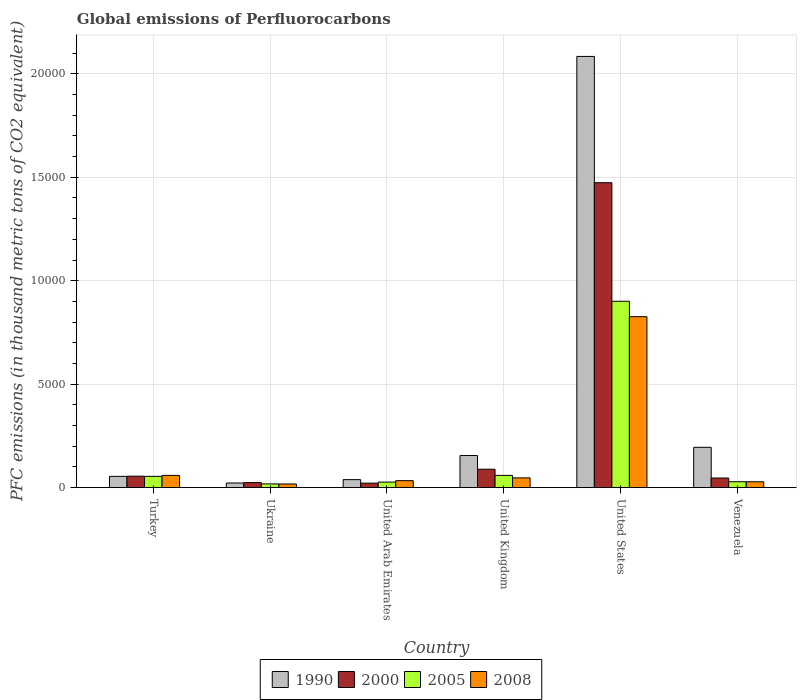How many different coloured bars are there?
Make the answer very short. 4. How many bars are there on the 4th tick from the right?
Provide a succinct answer. 4. What is the label of the 2nd group of bars from the left?
Ensure brevity in your answer.  Ukraine. In how many cases, is the number of bars for a given country not equal to the number of legend labels?
Your answer should be compact. 0. What is the global emissions of Perfluorocarbons in 2008 in United States?
Provide a succinct answer. 8264. Across all countries, what is the maximum global emissions of Perfluorocarbons in 2000?
Provide a succinct answer. 1.47e+04. Across all countries, what is the minimum global emissions of Perfluorocarbons in 2005?
Ensure brevity in your answer.  180.5. In which country was the global emissions of Perfluorocarbons in 2008 maximum?
Make the answer very short. United States. In which country was the global emissions of Perfluorocarbons in 2000 minimum?
Offer a very short reply. United Arab Emirates. What is the total global emissions of Perfluorocarbons in 2005 in the graph?
Offer a terse response. 1.09e+04. What is the difference between the global emissions of Perfluorocarbons in 2005 in United Arab Emirates and that in Venezuela?
Your response must be concise. -18.2. What is the difference between the global emissions of Perfluorocarbons in 2005 in Venezuela and the global emissions of Perfluorocarbons in 1990 in United States?
Offer a terse response. -2.06e+04. What is the average global emissions of Perfluorocarbons in 2008 per country?
Provide a succinct answer. 1687.62. What is the difference between the global emissions of Perfluorocarbons of/in 2005 and global emissions of Perfluorocarbons of/in 2000 in Ukraine?
Make the answer very short. -63.6. In how many countries, is the global emissions of Perfluorocarbons in 2000 greater than 2000 thousand metric tons?
Keep it short and to the point. 1. What is the ratio of the global emissions of Perfluorocarbons in 2005 in Ukraine to that in United Arab Emirates?
Provide a succinct answer. 0.67. Is the difference between the global emissions of Perfluorocarbons in 2005 in Ukraine and Venezuela greater than the difference between the global emissions of Perfluorocarbons in 2000 in Ukraine and Venezuela?
Ensure brevity in your answer.  Yes. What is the difference between the highest and the second highest global emissions of Perfluorocarbons in 2000?
Offer a terse response. -1.38e+04. What is the difference between the highest and the lowest global emissions of Perfluorocarbons in 1990?
Your answer should be very brief. 2.06e+04. Is the sum of the global emissions of Perfluorocarbons in 2000 in Turkey and United States greater than the maximum global emissions of Perfluorocarbons in 2005 across all countries?
Your answer should be compact. Yes. What does the 3rd bar from the right in Venezuela represents?
Keep it short and to the point. 2000. Is it the case that in every country, the sum of the global emissions of Perfluorocarbons in 1990 and global emissions of Perfluorocarbons in 2008 is greater than the global emissions of Perfluorocarbons in 2000?
Make the answer very short. Yes. What is the difference between two consecutive major ticks on the Y-axis?
Provide a short and direct response. 5000. Where does the legend appear in the graph?
Your response must be concise. Bottom center. What is the title of the graph?
Provide a succinct answer. Global emissions of Perfluorocarbons. What is the label or title of the X-axis?
Your answer should be compact. Country. What is the label or title of the Y-axis?
Make the answer very short. PFC emissions (in thousand metric tons of CO2 equivalent). What is the PFC emissions (in thousand metric tons of CO2 equivalent) in 1990 in Turkey?
Make the answer very short. 545.6. What is the PFC emissions (in thousand metric tons of CO2 equivalent) in 2000 in Turkey?
Your response must be concise. 554.9. What is the PFC emissions (in thousand metric tons of CO2 equivalent) in 2005 in Turkey?
Keep it short and to the point. 545.9. What is the PFC emissions (in thousand metric tons of CO2 equivalent) in 2008 in Turkey?
Provide a short and direct response. 591.4. What is the PFC emissions (in thousand metric tons of CO2 equivalent) of 1990 in Ukraine?
Keep it short and to the point. 224. What is the PFC emissions (in thousand metric tons of CO2 equivalent) in 2000 in Ukraine?
Give a very brief answer. 244.1. What is the PFC emissions (in thousand metric tons of CO2 equivalent) in 2005 in Ukraine?
Keep it short and to the point. 180.5. What is the PFC emissions (in thousand metric tons of CO2 equivalent) in 2008 in Ukraine?
Your response must be concise. 176.5. What is the PFC emissions (in thousand metric tons of CO2 equivalent) of 1990 in United Arab Emirates?
Provide a short and direct response. 387.3. What is the PFC emissions (in thousand metric tons of CO2 equivalent) of 2000 in United Arab Emirates?
Provide a succinct answer. 218. What is the PFC emissions (in thousand metric tons of CO2 equivalent) in 2005 in United Arab Emirates?
Your answer should be compact. 267.9. What is the PFC emissions (in thousand metric tons of CO2 equivalent) in 2008 in United Arab Emirates?
Provide a short and direct response. 337.6. What is the PFC emissions (in thousand metric tons of CO2 equivalent) in 1990 in United Kingdom?
Give a very brief answer. 1552.5. What is the PFC emissions (in thousand metric tons of CO2 equivalent) of 2000 in United Kingdom?
Provide a succinct answer. 890.1. What is the PFC emissions (in thousand metric tons of CO2 equivalent) in 2005 in United Kingdom?
Offer a terse response. 591.4. What is the PFC emissions (in thousand metric tons of CO2 equivalent) in 2008 in United Kingdom?
Give a very brief answer. 472.4. What is the PFC emissions (in thousand metric tons of CO2 equivalent) of 1990 in United States?
Your answer should be very brief. 2.08e+04. What is the PFC emissions (in thousand metric tons of CO2 equivalent) of 2000 in United States?
Your response must be concise. 1.47e+04. What is the PFC emissions (in thousand metric tons of CO2 equivalent) in 2005 in United States?
Your response must be concise. 9008.7. What is the PFC emissions (in thousand metric tons of CO2 equivalent) in 2008 in United States?
Give a very brief answer. 8264. What is the PFC emissions (in thousand metric tons of CO2 equivalent) of 1990 in Venezuela?
Ensure brevity in your answer.  1948.7. What is the PFC emissions (in thousand metric tons of CO2 equivalent) of 2000 in Venezuela?
Make the answer very short. 464.6. What is the PFC emissions (in thousand metric tons of CO2 equivalent) in 2005 in Venezuela?
Make the answer very short. 286.1. What is the PFC emissions (in thousand metric tons of CO2 equivalent) of 2008 in Venezuela?
Provide a short and direct response. 283.8. Across all countries, what is the maximum PFC emissions (in thousand metric tons of CO2 equivalent) of 1990?
Your response must be concise. 2.08e+04. Across all countries, what is the maximum PFC emissions (in thousand metric tons of CO2 equivalent) in 2000?
Offer a terse response. 1.47e+04. Across all countries, what is the maximum PFC emissions (in thousand metric tons of CO2 equivalent) in 2005?
Offer a terse response. 9008.7. Across all countries, what is the maximum PFC emissions (in thousand metric tons of CO2 equivalent) of 2008?
Make the answer very short. 8264. Across all countries, what is the minimum PFC emissions (in thousand metric tons of CO2 equivalent) in 1990?
Provide a succinct answer. 224. Across all countries, what is the minimum PFC emissions (in thousand metric tons of CO2 equivalent) of 2000?
Keep it short and to the point. 218. Across all countries, what is the minimum PFC emissions (in thousand metric tons of CO2 equivalent) in 2005?
Make the answer very short. 180.5. Across all countries, what is the minimum PFC emissions (in thousand metric tons of CO2 equivalent) of 2008?
Your answer should be compact. 176.5. What is the total PFC emissions (in thousand metric tons of CO2 equivalent) of 1990 in the graph?
Provide a short and direct response. 2.55e+04. What is the total PFC emissions (in thousand metric tons of CO2 equivalent) of 2000 in the graph?
Make the answer very short. 1.71e+04. What is the total PFC emissions (in thousand metric tons of CO2 equivalent) in 2005 in the graph?
Keep it short and to the point. 1.09e+04. What is the total PFC emissions (in thousand metric tons of CO2 equivalent) in 2008 in the graph?
Make the answer very short. 1.01e+04. What is the difference between the PFC emissions (in thousand metric tons of CO2 equivalent) in 1990 in Turkey and that in Ukraine?
Provide a succinct answer. 321.6. What is the difference between the PFC emissions (in thousand metric tons of CO2 equivalent) of 2000 in Turkey and that in Ukraine?
Make the answer very short. 310.8. What is the difference between the PFC emissions (in thousand metric tons of CO2 equivalent) in 2005 in Turkey and that in Ukraine?
Provide a succinct answer. 365.4. What is the difference between the PFC emissions (in thousand metric tons of CO2 equivalent) of 2008 in Turkey and that in Ukraine?
Your answer should be very brief. 414.9. What is the difference between the PFC emissions (in thousand metric tons of CO2 equivalent) in 1990 in Turkey and that in United Arab Emirates?
Your answer should be compact. 158.3. What is the difference between the PFC emissions (in thousand metric tons of CO2 equivalent) in 2000 in Turkey and that in United Arab Emirates?
Your response must be concise. 336.9. What is the difference between the PFC emissions (in thousand metric tons of CO2 equivalent) of 2005 in Turkey and that in United Arab Emirates?
Your response must be concise. 278. What is the difference between the PFC emissions (in thousand metric tons of CO2 equivalent) of 2008 in Turkey and that in United Arab Emirates?
Provide a short and direct response. 253.8. What is the difference between the PFC emissions (in thousand metric tons of CO2 equivalent) in 1990 in Turkey and that in United Kingdom?
Give a very brief answer. -1006.9. What is the difference between the PFC emissions (in thousand metric tons of CO2 equivalent) in 2000 in Turkey and that in United Kingdom?
Give a very brief answer. -335.2. What is the difference between the PFC emissions (in thousand metric tons of CO2 equivalent) of 2005 in Turkey and that in United Kingdom?
Ensure brevity in your answer.  -45.5. What is the difference between the PFC emissions (in thousand metric tons of CO2 equivalent) in 2008 in Turkey and that in United Kingdom?
Offer a terse response. 119. What is the difference between the PFC emissions (in thousand metric tons of CO2 equivalent) of 1990 in Turkey and that in United States?
Your answer should be compact. -2.03e+04. What is the difference between the PFC emissions (in thousand metric tons of CO2 equivalent) in 2000 in Turkey and that in United States?
Provide a succinct answer. -1.42e+04. What is the difference between the PFC emissions (in thousand metric tons of CO2 equivalent) of 2005 in Turkey and that in United States?
Your answer should be very brief. -8462.8. What is the difference between the PFC emissions (in thousand metric tons of CO2 equivalent) in 2008 in Turkey and that in United States?
Provide a short and direct response. -7672.6. What is the difference between the PFC emissions (in thousand metric tons of CO2 equivalent) of 1990 in Turkey and that in Venezuela?
Your answer should be very brief. -1403.1. What is the difference between the PFC emissions (in thousand metric tons of CO2 equivalent) of 2000 in Turkey and that in Venezuela?
Keep it short and to the point. 90.3. What is the difference between the PFC emissions (in thousand metric tons of CO2 equivalent) of 2005 in Turkey and that in Venezuela?
Your response must be concise. 259.8. What is the difference between the PFC emissions (in thousand metric tons of CO2 equivalent) in 2008 in Turkey and that in Venezuela?
Your response must be concise. 307.6. What is the difference between the PFC emissions (in thousand metric tons of CO2 equivalent) of 1990 in Ukraine and that in United Arab Emirates?
Ensure brevity in your answer.  -163.3. What is the difference between the PFC emissions (in thousand metric tons of CO2 equivalent) in 2000 in Ukraine and that in United Arab Emirates?
Your answer should be compact. 26.1. What is the difference between the PFC emissions (in thousand metric tons of CO2 equivalent) of 2005 in Ukraine and that in United Arab Emirates?
Ensure brevity in your answer.  -87.4. What is the difference between the PFC emissions (in thousand metric tons of CO2 equivalent) of 2008 in Ukraine and that in United Arab Emirates?
Give a very brief answer. -161.1. What is the difference between the PFC emissions (in thousand metric tons of CO2 equivalent) of 1990 in Ukraine and that in United Kingdom?
Ensure brevity in your answer.  -1328.5. What is the difference between the PFC emissions (in thousand metric tons of CO2 equivalent) in 2000 in Ukraine and that in United Kingdom?
Your answer should be compact. -646. What is the difference between the PFC emissions (in thousand metric tons of CO2 equivalent) of 2005 in Ukraine and that in United Kingdom?
Give a very brief answer. -410.9. What is the difference between the PFC emissions (in thousand metric tons of CO2 equivalent) of 2008 in Ukraine and that in United Kingdom?
Your response must be concise. -295.9. What is the difference between the PFC emissions (in thousand metric tons of CO2 equivalent) of 1990 in Ukraine and that in United States?
Offer a terse response. -2.06e+04. What is the difference between the PFC emissions (in thousand metric tons of CO2 equivalent) of 2000 in Ukraine and that in United States?
Make the answer very short. -1.45e+04. What is the difference between the PFC emissions (in thousand metric tons of CO2 equivalent) of 2005 in Ukraine and that in United States?
Ensure brevity in your answer.  -8828.2. What is the difference between the PFC emissions (in thousand metric tons of CO2 equivalent) in 2008 in Ukraine and that in United States?
Ensure brevity in your answer.  -8087.5. What is the difference between the PFC emissions (in thousand metric tons of CO2 equivalent) in 1990 in Ukraine and that in Venezuela?
Ensure brevity in your answer.  -1724.7. What is the difference between the PFC emissions (in thousand metric tons of CO2 equivalent) in 2000 in Ukraine and that in Venezuela?
Offer a terse response. -220.5. What is the difference between the PFC emissions (in thousand metric tons of CO2 equivalent) of 2005 in Ukraine and that in Venezuela?
Provide a succinct answer. -105.6. What is the difference between the PFC emissions (in thousand metric tons of CO2 equivalent) in 2008 in Ukraine and that in Venezuela?
Keep it short and to the point. -107.3. What is the difference between the PFC emissions (in thousand metric tons of CO2 equivalent) in 1990 in United Arab Emirates and that in United Kingdom?
Offer a very short reply. -1165.2. What is the difference between the PFC emissions (in thousand metric tons of CO2 equivalent) of 2000 in United Arab Emirates and that in United Kingdom?
Make the answer very short. -672.1. What is the difference between the PFC emissions (in thousand metric tons of CO2 equivalent) in 2005 in United Arab Emirates and that in United Kingdom?
Make the answer very short. -323.5. What is the difference between the PFC emissions (in thousand metric tons of CO2 equivalent) in 2008 in United Arab Emirates and that in United Kingdom?
Make the answer very short. -134.8. What is the difference between the PFC emissions (in thousand metric tons of CO2 equivalent) of 1990 in United Arab Emirates and that in United States?
Give a very brief answer. -2.05e+04. What is the difference between the PFC emissions (in thousand metric tons of CO2 equivalent) in 2000 in United Arab Emirates and that in United States?
Your response must be concise. -1.45e+04. What is the difference between the PFC emissions (in thousand metric tons of CO2 equivalent) of 2005 in United Arab Emirates and that in United States?
Your response must be concise. -8740.8. What is the difference between the PFC emissions (in thousand metric tons of CO2 equivalent) of 2008 in United Arab Emirates and that in United States?
Provide a succinct answer. -7926.4. What is the difference between the PFC emissions (in thousand metric tons of CO2 equivalent) of 1990 in United Arab Emirates and that in Venezuela?
Your response must be concise. -1561.4. What is the difference between the PFC emissions (in thousand metric tons of CO2 equivalent) in 2000 in United Arab Emirates and that in Venezuela?
Your response must be concise. -246.6. What is the difference between the PFC emissions (in thousand metric tons of CO2 equivalent) in 2005 in United Arab Emirates and that in Venezuela?
Your answer should be compact. -18.2. What is the difference between the PFC emissions (in thousand metric tons of CO2 equivalent) in 2008 in United Arab Emirates and that in Venezuela?
Give a very brief answer. 53.8. What is the difference between the PFC emissions (in thousand metric tons of CO2 equivalent) of 1990 in United Kingdom and that in United States?
Your answer should be very brief. -1.93e+04. What is the difference between the PFC emissions (in thousand metric tons of CO2 equivalent) of 2000 in United Kingdom and that in United States?
Offer a very short reply. -1.38e+04. What is the difference between the PFC emissions (in thousand metric tons of CO2 equivalent) in 2005 in United Kingdom and that in United States?
Make the answer very short. -8417.3. What is the difference between the PFC emissions (in thousand metric tons of CO2 equivalent) in 2008 in United Kingdom and that in United States?
Your response must be concise. -7791.6. What is the difference between the PFC emissions (in thousand metric tons of CO2 equivalent) in 1990 in United Kingdom and that in Venezuela?
Keep it short and to the point. -396.2. What is the difference between the PFC emissions (in thousand metric tons of CO2 equivalent) in 2000 in United Kingdom and that in Venezuela?
Give a very brief answer. 425.5. What is the difference between the PFC emissions (in thousand metric tons of CO2 equivalent) of 2005 in United Kingdom and that in Venezuela?
Offer a very short reply. 305.3. What is the difference between the PFC emissions (in thousand metric tons of CO2 equivalent) of 2008 in United Kingdom and that in Venezuela?
Offer a very short reply. 188.6. What is the difference between the PFC emissions (in thousand metric tons of CO2 equivalent) in 1990 in United States and that in Venezuela?
Provide a short and direct response. 1.89e+04. What is the difference between the PFC emissions (in thousand metric tons of CO2 equivalent) of 2000 in United States and that in Venezuela?
Make the answer very short. 1.43e+04. What is the difference between the PFC emissions (in thousand metric tons of CO2 equivalent) in 2005 in United States and that in Venezuela?
Make the answer very short. 8722.6. What is the difference between the PFC emissions (in thousand metric tons of CO2 equivalent) in 2008 in United States and that in Venezuela?
Give a very brief answer. 7980.2. What is the difference between the PFC emissions (in thousand metric tons of CO2 equivalent) of 1990 in Turkey and the PFC emissions (in thousand metric tons of CO2 equivalent) of 2000 in Ukraine?
Your answer should be compact. 301.5. What is the difference between the PFC emissions (in thousand metric tons of CO2 equivalent) of 1990 in Turkey and the PFC emissions (in thousand metric tons of CO2 equivalent) of 2005 in Ukraine?
Give a very brief answer. 365.1. What is the difference between the PFC emissions (in thousand metric tons of CO2 equivalent) in 1990 in Turkey and the PFC emissions (in thousand metric tons of CO2 equivalent) in 2008 in Ukraine?
Offer a very short reply. 369.1. What is the difference between the PFC emissions (in thousand metric tons of CO2 equivalent) of 2000 in Turkey and the PFC emissions (in thousand metric tons of CO2 equivalent) of 2005 in Ukraine?
Your answer should be very brief. 374.4. What is the difference between the PFC emissions (in thousand metric tons of CO2 equivalent) in 2000 in Turkey and the PFC emissions (in thousand metric tons of CO2 equivalent) in 2008 in Ukraine?
Make the answer very short. 378.4. What is the difference between the PFC emissions (in thousand metric tons of CO2 equivalent) of 2005 in Turkey and the PFC emissions (in thousand metric tons of CO2 equivalent) of 2008 in Ukraine?
Keep it short and to the point. 369.4. What is the difference between the PFC emissions (in thousand metric tons of CO2 equivalent) in 1990 in Turkey and the PFC emissions (in thousand metric tons of CO2 equivalent) in 2000 in United Arab Emirates?
Give a very brief answer. 327.6. What is the difference between the PFC emissions (in thousand metric tons of CO2 equivalent) of 1990 in Turkey and the PFC emissions (in thousand metric tons of CO2 equivalent) of 2005 in United Arab Emirates?
Keep it short and to the point. 277.7. What is the difference between the PFC emissions (in thousand metric tons of CO2 equivalent) in 1990 in Turkey and the PFC emissions (in thousand metric tons of CO2 equivalent) in 2008 in United Arab Emirates?
Make the answer very short. 208. What is the difference between the PFC emissions (in thousand metric tons of CO2 equivalent) in 2000 in Turkey and the PFC emissions (in thousand metric tons of CO2 equivalent) in 2005 in United Arab Emirates?
Provide a short and direct response. 287. What is the difference between the PFC emissions (in thousand metric tons of CO2 equivalent) of 2000 in Turkey and the PFC emissions (in thousand metric tons of CO2 equivalent) of 2008 in United Arab Emirates?
Offer a very short reply. 217.3. What is the difference between the PFC emissions (in thousand metric tons of CO2 equivalent) in 2005 in Turkey and the PFC emissions (in thousand metric tons of CO2 equivalent) in 2008 in United Arab Emirates?
Keep it short and to the point. 208.3. What is the difference between the PFC emissions (in thousand metric tons of CO2 equivalent) in 1990 in Turkey and the PFC emissions (in thousand metric tons of CO2 equivalent) in 2000 in United Kingdom?
Make the answer very short. -344.5. What is the difference between the PFC emissions (in thousand metric tons of CO2 equivalent) of 1990 in Turkey and the PFC emissions (in thousand metric tons of CO2 equivalent) of 2005 in United Kingdom?
Your response must be concise. -45.8. What is the difference between the PFC emissions (in thousand metric tons of CO2 equivalent) in 1990 in Turkey and the PFC emissions (in thousand metric tons of CO2 equivalent) in 2008 in United Kingdom?
Offer a very short reply. 73.2. What is the difference between the PFC emissions (in thousand metric tons of CO2 equivalent) in 2000 in Turkey and the PFC emissions (in thousand metric tons of CO2 equivalent) in 2005 in United Kingdom?
Give a very brief answer. -36.5. What is the difference between the PFC emissions (in thousand metric tons of CO2 equivalent) in 2000 in Turkey and the PFC emissions (in thousand metric tons of CO2 equivalent) in 2008 in United Kingdom?
Your response must be concise. 82.5. What is the difference between the PFC emissions (in thousand metric tons of CO2 equivalent) in 2005 in Turkey and the PFC emissions (in thousand metric tons of CO2 equivalent) in 2008 in United Kingdom?
Your answer should be very brief. 73.5. What is the difference between the PFC emissions (in thousand metric tons of CO2 equivalent) of 1990 in Turkey and the PFC emissions (in thousand metric tons of CO2 equivalent) of 2000 in United States?
Your answer should be compact. -1.42e+04. What is the difference between the PFC emissions (in thousand metric tons of CO2 equivalent) of 1990 in Turkey and the PFC emissions (in thousand metric tons of CO2 equivalent) of 2005 in United States?
Your answer should be compact. -8463.1. What is the difference between the PFC emissions (in thousand metric tons of CO2 equivalent) of 1990 in Turkey and the PFC emissions (in thousand metric tons of CO2 equivalent) of 2008 in United States?
Offer a very short reply. -7718.4. What is the difference between the PFC emissions (in thousand metric tons of CO2 equivalent) in 2000 in Turkey and the PFC emissions (in thousand metric tons of CO2 equivalent) in 2005 in United States?
Your answer should be compact. -8453.8. What is the difference between the PFC emissions (in thousand metric tons of CO2 equivalent) of 2000 in Turkey and the PFC emissions (in thousand metric tons of CO2 equivalent) of 2008 in United States?
Keep it short and to the point. -7709.1. What is the difference between the PFC emissions (in thousand metric tons of CO2 equivalent) of 2005 in Turkey and the PFC emissions (in thousand metric tons of CO2 equivalent) of 2008 in United States?
Your answer should be compact. -7718.1. What is the difference between the PFC emissions (in thousand metric tons of CO2 equivalent) in 1990 in Turkey and the PFC emissions (in thousand metric tons of CO2 equivalent) in 2000 in Venezuela?
Keep it short and to the point. 81. What is the difference between the PFC emissions (in thousand metric tons of CO2 equivalent) of 1990 in Turkey and the PFC emissions (in thousand metric tons of CO2 equivalent) of 2005 in Venezuela?
Your response must be concise. 259.5. What is the difference between the PFC emissions (in thousand metric tons of CO2 equivalent) of 1990 in Turkey and the PFC emissions (in thousand metric tons of CO2 equivalent) of 2008 in Venezuela?
Your answer should be very brief. 261.8. What is the difference between the PFC emissions (in thousand metric tons of CO2 equivalent) in 2000 in Turkey and the PFC emissions (in thousand metric tons of CO2 equivalent) in 2005 in Venezuela?
Offer a terse response. 268.8. What is the difference between the PFC emissions (in thousand metric tons of CO2 equivalent) in 2000 in Turkey and the PFC emissions (in thousand metric tons of CO2 equivalent) in 2008 in Venezuela?
Provide a succinct answer. 271.1. What is the difference between the PFC emissions (in thousand metric tons of CO2 equivalent) in 2005 in Turkey and the PFC emissions (in thousand metric tons of CO2 equivalent) in 2008 in Venezuela?
Your answer should be compact. 262.1. What is the difference between the PFC emissions (in thousand metric tons of CO2 equivalent) of 1990 in Ukraine and the PFC emissions (in thousand metric tons of CO2 equivalent) of 2000 in United Arab Emirates?
Keep it short and to the point. 6. What is the difference between the PFC emissions (in thousand metric tons of CO2 equivalent) in 1990 in Ukraine and the PFC emissions (in thousand metric tons of CO2 equivalent) in 2005 in United Arab Emirates?
Offer a terse response. -43.9. What is the difference between the PFC emissions (in thousand metric tons of CO2 equivalent) in 1990 in Ukraine and the PFC emissions (in thousand metric tons of CO2 equivalent) in 2008 in United Arab Emirates?
Give a very brief answer. -113.6. What is the difference between the PFC emissions (in thousand metric tons of CO2 equivalent) in 2000 in Ukraine and the PFC emissions (in thousand metric tons of CO2 equivalent) in 2005 in United Arab Emirates?
Give a very brief answer. -23.8. What is the difference between the PFC emissions (in thousand metric tons of CO2 equivalent) of 2000 in Ukraine and the PFC emissions (in thousand metric tons of CO2 equivalent) of 2008 in United Arab Emirates?
Give a very brief answer. -93.5. What is the difference between the PFC emissions (in thousand metric tons of CO2 equivalent) in 2005 in Ukraine and the PFC emissions (in thousand metric tons of CO2 equivalent) in 2008 in United Arab Emirates?
Ensure brevity in your answer.  -157.1. What is the difference between the PFC emissions (in thousand metric tons of CO2 equivalent) of 1990 in Ukraine and the PFC emissions (in thousand metric tons of CO2 equivalent) of 2000 in United Kingdom?
Your answer should be compact. -666.1. What is the difference between the PFC emissions (in thousand metric tons of CO2 equivalent) of 1990 in Ukraine and the PFC emissions (in thousand metric tons of CO2 equivalent) of 2005 in United Kingdom?
Your answer should be compact. -367.4. What is the difference between the PFC emissions (in thousand metric tons of CO2 equivalent) of 1990 in Ukraine and the PFC emissions (in thousand metric tons of CO2 equivalent) of 2008 in United Kingdom?
Give a very brief answer. -248.4. What is the difference between the PFC emissions (in thousand metric tons of CO2 equivalent) in 2000 in Ukraine and the PFC emissions (in thousand metric tons of CO2 equivalent) in 2005 in United Kingdom?
Give a very brief answer. -347.3. What is the difference between the PFC emissions (in thousand metric tons of CO2 equivalent) of 2000 in Ukraine and the PFC emissions (in thousand metric tons of CO2 equivalent) of 2008 in United Kingdom?
Offer a terse response. -228.3. What is the difference between the PFC emissions (in thousand metric tons of CO2 equivalent) of 2005 in Ukraine and the PFC emissions (in thousand metric tons of CO2 equivalent) of 2008 in United Kingdom?
Offer a very short reply. -291.9. What is the difference between the PFC emissions (in thousand metric tons of CO2 equivalent) in 1990 in Ukraine and the PFC emissions (in thousand metric tons of CO2 equivalent) in 2000 in United States?
Keep it short and to the point. -1.45e+04. What is the difference between the PFC emissions (in thousand metric tons of CO2 equivalent) in 1990 in Ukraine and the PFC emissions (in thousand metric tons of CO2 equivalent) in 2005 in United States?
Ensure brevity in your answer.  -8784.7. What is the difference between the PFC emissions (in thousand metric tons of CO2 equivalent) in 1990 in Ukraine and the PFC emissions (in thousand metric tons of CO2 equivalent) in 2008 in United States?
Give a very brief answer. -8040. What is the difference between the PFC emissions (in thousand metric tons of CO2 equivalent) of 2000 in Ukraine and the PFC emissions (in thousand metric tons of CO2 equivalent) of 2005 in United States?
Your response must be concise. -8764.6. What is the difference between the PFC emissions (in thousand metric tons of CO2 equivalent) of 2000 in Ukraine and the PFC emissions (in thousand metric tons of CO2 equivalent) of 2008 in United States?
Ensure brevity in your answer.  -8019.9. What is the difference between the PFC emissions (in thousand metric tons of CO2 equivalent) of 2005 in Ukraine and the PFC emissions (in thousand metric tons of CO2 equivalent) of 2008 in United States?
Offer a very short reply. -8083.5. What is the difference between the PFC emissions (in thousand metric tons of CO2 equivalent) of 1990 in Ukraine and the PFC emissions (in thousand metric tons of CO2 equivalent) of 2000 in Venezuela?
Provide a succinct answer. -240.6. What is the difference between the PFC emissions (in thousand metric tons of CO2 equivalent) of 1990 in Ukraine and the PFC emissions (in thousand metric tons of CO2 equivalent) of 2005 in Venezuela?
Your answer should be very brief. -62.1. What is the difference between the PFC emissions (in thousand metric tons of CO2 equivalent) in 1990 in Ukraine and the PFC emissions (in thousand metric tons of CO2 equivalent) in 2008 in Venezuela?
Offer a terse response. -59.8. What is the difference between the PFC emissions (in thousand metric tons of CO2 equivalent) in 2000 in Ukraine and the PFC emissions (in thousand metric tons of CO2 equivalent) in 2005 in Venezuela?
Your response must be concise. -42. What is the difference between the PFC emissions (in thousand metric tons of CO2 equivalent) in 2000 in Ukraine and the PFC emissions (in thousand metric tons of CO2 equivalent) in 2008 in Venezuela?
Your answer should be very brief. -39.7. What is the difference between the PFC emissions (in thousand metric tons of CO2 equivalent) in 2005 in Ukraine and the PFC emissions (in thousand metric tons of CO2 equivalent) in 2008 in Venezuela?
Provide a succinct answer. -103.3. What is the difference between the PFC emissions (in thousand metric tons of CO2 equivalent) in 1990 in United Arab Emirates and the PFC emissions (in thousand metric tons of CO2 equivalent) in 2000 in United Kingdom?
Your answer should be very brief. -502.8. What is the difference between the PFC emissions (in thousand metric tons of CO2 equivalent) in 1990 in United Arab Emirates and the PFC emissions (in thousand metric tons of CO2 equivalent) in 2005 in United Kingdom?
Your answer should be compact. -204.1. What is the difference between the PFC emissions (in thousand metric tons of CO2 equivalent) of 1990 in United Arab Emirates and the PFC emissions (in thousand metric tons of CO2 equivalent) of 2008 in United Kingdom?
Your answer should be compact. -85.1. What is the difference between the PFC emissions (in thousand metric tons of CO2 equivalent) in 2000 in United Arab Emirates and the PFC emissions (in thousand metric tons of CO2 equivalent) in 2005 in United Kingdom?
Make the answer very short. -373.4. What is the difference between the PFC emissions (in thousand metric tons of CO2 equivalent) in 2000 in United Arab Emirates and the PFC emissions (in thousand metric tons of CO2 equivalent) in 2008 in United Kingdom?
Give a very brief answer. -254.4. What is the difference between the PFC emissions (in thousand metric tons of CO2 equivalent) of 2005 in United Arab Emirates and the PFC emissions (in thousand metric tons of CO2 equivalent) of 2008 in United Kingdom?
Keep it short and to the point. -204.5. What is the difference between the PFC emissions (in thousand metric tons of CO2 equivalent) of 1990 in United Arab Emirates and the PFC emissions (in thousand metric tons of CO2 equivalent) of 2000 in United States?
Provide a short and direct response. -1.44e+04. What is the difference between the PFC emissions (in thousand metric tons of CO2 equivalent) in 1990 in United Arab Emirates and the PFC emissions (in thousand metric tons of CO2 equivalent) in 2005 in United States?
Ensure brevity in your answer.  -8621.4. What is the difference between the PFC emissions (in thousand metric tons of CO2 equivalent) in 1990 in United Arab Emirates and the PFC emissions (in thousand metric tons of CO2 equivalent) in 2008 in United States?
Ensure brevity in your answer.  -7876.7. What is the difference between the PFC emissions (in thousand metric tons of CO2 equivalent) of 2000 in United Arab Emirates and the PFC emissions (in thousand metric tons of CO2 equivalent) of 2005 in United States?
Keep it short and to the point. -8790.7. What is the difference between the PFC emissions (in thousand metric tons of CO2 equivalent) of 2000 in United Arab Emirates and the PFC emissions (in thousand metric tons of CO2 equivalent) of 2008 in United States?
Provide a succinct answer. -8046. What is the difference between the PFC emissions (in thousand metric tons of CO2 equivalent) of 2005 in United Arab Emirates and the PFC emissions (in thousand metric tons of CO2 equivalent) of 2008 in United States?
Make the answer very short. -7996.1. What is the difference between the PFC emissions (in thousand metric tons of CO2 equivalent) in 1990 in United Arab Emirates and the PFC emissions (in thousand metric tons of CO2 equivalent) in 2000 in Venezuela?
Ensure brevity in your answer.  -77.3. What is the difference between the PFC emissions (in thousand metric tons of CO2 equivalent) in 1990 in United Arab Emirates and the PFC emissions (in thousand metric tons of CO2 equivalent) in 2005 in Venezuela?
Give a very brief answer. 101.2. What is the difference between the PFC emissions (in thousand metric tons of CO2 equivalent) of 1990 in United Arab Emirates and the PFC emissions (in thousand metric tons of CO2 equivalent) of 2008 in Venezuela?
Make the answer very short. 103.5. What is the difference between the PFC emissions (in thousand metric tons of CO2 equivalent) of 2000 in United Arab Emirates and the PFC emissions (in thousand metric tons of CO2 equivalent) of 2005 in Venezuela?
Ensure brevity in your answer.  -68.1. What is the difference between the PFC emissions (in thousand metric tons of CO2 equivalent) in 2000 in United Arab Emirates and the PFC emissions (in thousand metric tons of CO2 equivalent) in 2008 in Venezuela?
Make the answer very short. -65.8. What is the difference between the PFC emissions (in thousand metric tons of CO2 equivalent) of 2005 in United Arab Emirates and the PFC emissions (in thousand metric tons of CO2 equivalent) of 2008 in Venezuela?
Your answer should be compact. -15.9. What is the difference between the PFC emissions (in thousand metric tons of CO2 equivalent) in 1990 in United Kingdom and the PFC emissions (in thousand metric tons of CO2 equivalent) in 2000 in United States?
Your response must be concise. -1.32e+04. What is the difference between the PFC emissions (in thousand metric tons of CO2 equivalent) in 1990 in United Kingdom and the PFC emissions (in thousand metric tons of CO2 equivalent) in 2005 in United States?
Provide a succinct answer. -7456.2. What is the difference between the PFC emissions (in thousand metric tons of CO2 equivalent) in 1990 in United Kingdom and the PFC emissions (in thousand metric tons of CO2 equivalent) in 2008 in United States?
Your answer should be compact. -6711.5. What is the difference between the PFC emissions (in thousand metric tons of CO2 equivalent) of 2000 in United Kingdom and the PFC emissions (in thousand metric tons of CO2 equivalent) of 2005 in United States?
Your answer should be compact. -8118.6. What is the difference between the PFC emissions (in thousand metric tons of CO2 equivalent) of 2000 in United Kingdom and the PFC emissions (in thousand metric tons of CO2 equivalent) of 2008 in United States?
Offer a very short reply. -7373.9. What is the difference between the PFC emissions (in thousand metric tons of CO2 equivalent) in 2005 in United Kingdom and the PFC emissions (in thousand metric tons of CO2 equivalent) in 2008 in United States?
Your answer should be compact. -7672.6. What is the difference between the PFC emissions (in thousand metric tons of CO2 equivalent) in 1990 in United Kingdom and the PFC emissions (in thousand metric tons of CO2 equivalent) in 2000 in Venezuela?
Provide a succinct answer. 1087.9. What is the difference between the PFC emissions (in thousand metric tons of CO2 equivalent) of 1990 in United Kingdom and the PFC emissions (in thousand metric tons of CO2 equivalent) of 2005 in Venezuela?
Offer a terse response. 1266.4. What is the difference between the PFC emissions (in thousand metric tons of CO2 equivalent) in 1990 in United Kingdom and the PFC emissions (in thousand metric tons of CO2 equivalent) in 2008 in Venezuela?
Offer a very short reply. 1268.7. What is the difference between the PFC emissions (in thousand metric tons of CO2 equivalent) in 2000 in United Kingdom and the PFC emissions (in thousand metric tons of CO2 equivalent) in 2005 in Venezuela?
Your answer should be very brief. 604. What is the difference between the PFC emissions (in thousand metric tons of CO2 equivalent) in 2000 in United Kingdom and the PFC emissions (in thousand metric tons of CO2 equivalent) in 2008 in Venezuela?
Keep it short and to the point. 606.3. What is the difference between the PFC emissions (in thousand metric tons of CO2 equivalent) of 2005 in United Kingdom and the PFC emissions (in thousand metric tons of CO2 equivalent) of 2008 in Venezuela?
Ensure brevity in your answer.  307.6. What is the difference between the PFC emissions (in thousand metric tons of CO2 equivalent) in 1990 in United States and the PFC emissions (in thousand metric tons of CO2 equivalent) in 2000 in Venezuela?
Make the answer very short. 2.04e+04. What is the difference between the PFC emissions (in thousand metric tons of CO2 equivalent) of 1990 in United States and the PFC emissions (in thousand metric tons of CO2 equivalent) of 2005 in Venezuela?
Your answer should be very brief. 2.06e+04. What is the difference between the PFC emissions (in thousand metric tons of CO2 equivalent) of 1990 in United States and the PFC emissions (in thousand metric tons of CO2 equivalent) of 2008 in Venezuela?
Give a very brief answer. 2.06e+04. What is the difference between the PFC emissions (in thousand metric tons of CO2 equivalent) of 2000 in United States and the PFC emissions (in thousand metric tons of CO2 equivalent) of 2005 in Venezuela?
Provide a succinct answer. 1.45e+04. What is the difference between the PFC emissions (in thousand metric tons of CO2 equivalent) of 2000 in United States and the PFC emissions (in thousand metric tons of CO2 equivalent) of 2008 in Venezuela?
Give a very brief answer. 1.45e+04. What is the difference between the PFC emissions (in thousand metric tons of CO2 equivalent) in 2005 in United States and the PFC emissions (in thousand metric tons of CO2 equivalent) in 2008 in Venezuela?
Offer a terse response. 8724.9. What is the average PFC emissions (in thousand metric tons of CO2 equivalent) of 1990 per country?
Your answer should be very brief. 4249.9. What is the average PFC emissions (in thousand metric tons of CO2 equivalent) in 2000 per country?
Offer a very short reply. 2851.78. What is the average PFC emissions (in thousand metric tons of CO2 equivalent) of 2005 per country?
Offer a very short reply. 1813.42. What is the average PFC emissions (in thousand metric tons of CO2 equivalent) of 2008 per country?
Your response must be concise. 1687.62. What is the difference between the PFC emissions (in thousand metric tons of CO2 equivalent) of 1990 and PFC emissions (in thousand metric tons of CO2 equivalent) of 2000 in Turkey?
Offer a very short reply. -9.3. What is the difference between the PFC emissions (in thousand metric tons of CO2 equivalent) in 1990 and PFC emissions (in thousand metric tons of CO2 equivalent) in 2005 in Turkey?
Give a very brief answer. -0.3. What is the difference between the PFC emissions (in thousand metric tons of CO2 equivalent) of 1990 and PFC emissions (in thousand metric tons of CO2 equivalent) of 2008 in Turkey?
Provide a succinct answer. -45.8. What is the difference between the PFC emissions (in thousand metric tons of CO2 equivalent) of 2000 and PFC emissions (in thousand metric tons of CO2 equivalent) of 2005 in Turkey?
Offer a very short reply. 9. What is the difference between the PFC emissions (in thousand metric tons of CO2 equivalent) of 2000 and PFC emissions (in thousand metric tons of CO2 equivalent) of 2008 in Turkey?
Ensure brevity in your answer.  -36.5. What is the difference between the PFC emissions (in thousand metric tons of CO2 equivalent) of 2005 and PFC emissions (in thousand metric tons of CO2 equivalent) of 2008 in Turkey?
Give a very brief answer. -45.5. What is the difference between the PFC emissions (in thousand metric tons of CO2 equivalent) in 1990 and PFC emissions (in thousand metric tons of CO2 equivalent) in 2000 in Ukraine?
Make the answer very short. -20.1. What is the difference between the PFC emissions (in thousand metric tons of CO2 equivalent) of 1990 and PFC emissions (in thousand metric tons of CO2 equivalent) of 2005 in Ukraine?
Give a very brief answer. 43.5. What is the difference between the PFC emissions (in thousand metric tons of CO2 equivalent) of 1990 and PFC emissions (in thousand metric tons of CO2 equivalent) of 2008 in Ukraine?
Give a very brief answer. 47.5. What is the difference between the PFC emissions (in thousand metric tons of CO2 equivalent) of 2000 and PFC emissions (in thousand metric tons of CO2 equivalent) of 2005 in Ukraine?
Give a very brief answer. 63.6. What is the difference between the PFC emissions (in thousand metric tons of CO2 equivalent) in 2000 and PFC emissions (in thousand metric tons of CO2 equivalent) in 2008 in Ukraine?
Provide a short and direct response. 67.6. What is the difference between the PFC emissions (in thousand metric tons of CO2 equivalent) in 1990 and PFC emissions (in thousand metric tons of CO2 equivalent) in 2000 in United Arab Emirates?
Offer a very short reply. 169.3. What is the difference between the PFC emissions (in thousand metric tons of CO2 equivalent) of 1990 and PFC emissions (in thousand metric tons of CO2 equivalent) of 2005 in United Arab Emirates?
Offer a very short reply. 119.4. What is the difference between the PFC emissions (in thousand metric tons of CO2 equivalent) of 1990 and PFC emissions (in thousand metric tons of CO2 equivalent) of 2008 in United Arab Emirates?
Provide a short and direct response. 49.7. What is the difference between the PFC emissions (in thousand metric tons of CO2 equivalent) in 2000 and PFC emissions (in thousand metric tons of CO2 equivalent) in 2005 in United Arab Emirates?
Make the answer very short. -49.9. What is the difference between the PFC emissions (in thousand metric tons of CO2 equivalent) in 2000 and PFC emissions (in thousand metric tons of CO2 equivalent) in 2008 in United Arab Emirates?
Ensure brevity in your answer.  -119.6. What is the difference between the PFC emissions (in thousand metric tons of CO2 equivalent) in 2005 and PFC emissions (in thousand metric tons of CO2 equivalent) in 2008 in United Arab Emirates?
Your answer should be very brief. -69.7. What is the difference between the PFC emissions (in thousand metric tons of CO2 equivalent) of 1990 and PFC emissions (in thousand metric tons of CO2 equivalent) of 2000 in United Kingdom?
Ensure brevity in your answer.  662.4. What is the difference between the PFC emissions (in thousand metric tons of CO2 equivalent) of 1990 and PFC emissions (in thousand metric tons of CO2 equivalent) of 2005 in United Kingdom?
Your answer should be very brief. 961.1. What is the difference between the PFC emissions (in thousand metric tons of CO2 equivalent) in 1990 and PFC emissions (in thousand metric tons of CO2 equivalent) in 2008 in United Kingdom?
Your answer should be compact. 1080.1. What is the difference between the PFC emissions (in thousand metric tons of CO2 equivalent) of 2000 and PFC emissions (in thousand metric tons of CO2 equivalent) of 2005 in United Kingdom?
Offer a terse response. 298.7. What is the difference between the PFC emissions (in thousand metric tons of CO2 equivalent) of 2000 and PFC emissions (in thousand metric tons of CO2 equivalent) of 2008 in United Kingdom?
Provide a short and direct response. 417.7. What is the difference between the PFC emissions (in thousand metric tons of CO2 equivalent) in 2005 and PFC emissions (in thousand metric tons of CO2 equivalent) in 2008 in United Kingdom?
Give a very brief answer. 119. What is the difference between the PFC emissions (in thousand metric tons of CO2 equivalent) of 1990 and PFC emissions (in thousand metric tons of CO2 equivalent) of 2000 in United States?
Make the answer very short. 6102.3. What is the difference between the PFC emissions (in thousand metric tons of CO2 equivalent) in 1990 and PFC emissions (in thousand metric tons of CO2 equivalent) in 2005 in United States?
Give a very brief answer. 1.18e+04. What is the difference between the PFC emissions (in thousand metric tons of CO2 equivalent) of 1990 and PFC emissions (in thousand metric tons of CO2 equivalent) of 2008 in United States?
Offer a very short reply. 1.26e+04. What is the difference between the PFC emissions (in thousand metric tons of CO2 equivalent) in 2000 and PFC emissions (in thousand metric tons of CO2 equivalent) in 2005 in United States?
Provide a short and direct response. 5730.3. What is the difference between the PFC emissions (in thousand metric tons of CO2 equivalent) in 2000 and PFC emissions (in thousand metric tons of CO2 equivalent) in 2008 in United States?
Your response must be concise. 6475. What is the difference between the PFC emissions (in thousand metric tons of CO2 equivalent) of 2005 and PFC emissions (in thousand metric tons of CO2 equivalent) of 2008 in United States?
Your answer should be compact. 744.7. What is the difference between the PFC emissions (in thousand metric tons of CO2 equivalent) of 1990 and PFC emissions (in thousand metric tons of CO2 equivalent) of 2000 in Venezuela?
Your answer should be very brief. 1484.1. What is the difference between the PFC emissions (in thousand metric tons of CO2 equivalent) of 1990 and PFC emissions (in thousand metric tons of CO2 equivalent) of 2005 in Venezuela?
Provide a short and direct response. 1662.6. What is the difference between the PFC emissions (in thousand metric tons of CO2 equivalent) in 1990 and PFC emissions (in thousand metric tons of CO2 equivalent) in 2008 in Venezuela?
Make the answer very short. 1664.9. What is the difference between the PFC emissions (in thousand metric tons of CO2 equivalent) in 2000 and PFC emissions (in thousand metric tons of CO2 equivalent) in 2005 in Venezuela?
Give a very brief answer. 178.5. What is the difference between the PFC emissions (in thousand metric tons of CO2 equivalent) of 2000 and PFC emissions (in thousand metric tons of CO2 equivalent) of 2008 in Venezuela?
Keep it short and to the point. 180.8. What is the ratio of the PFC emissions (in thousand metric tons of CO2 equivalent) in 1990 in Turkey to that in Ukraine?
Provide a succinct answer. 2.44. What is the ratio of the PFC emissions (in thousand metric tons of CO2 equivalent) in 2000 in Turkey to that in Ukraine?
Your response must be concise. 2.27. What is the ratio of the PFC emissions (in thousand metric tons of CO2 equivalent) in 2005 in Turkey to that in Ukraine?
Give a very brief answer. 3.02. What is the ratio of the PFC emissions (in thousand metric tons of CO2 equivalent) of 2008 in Turkey to that in Ukraine?
Ensure brevity in your answer.  3.35. What is the ratio of the PFC emissions (in thousand metric tons of CO2 equivalent) of 1990 in Turkey to that in United Arab Emirates?
Your answer should be compact. 1.41. What is the ratio of the PFC emissions (in thousand metric tons of CO2 equivalent) in 2000 in Turkey to that in United Arab Emirates?
Offer a very short reply. 2.55. What is the ratio of the PFC emissions (in thousand metric tons of CO2 equivalent) of 2005 in Turkey to that in United Arab Emirates?
Provide a succinct answer. 2.04. What is the ratio of the PFC emissions (in thousand metric tons of CO2 equivalent) of 2008 in Turkey to that in United Arab Emirates?
Ensure brevity in your answer.  1.75. What is the ratio of the PFC emissions (in thousand metric tons of CO2 equivalent) in 1990 in Turkey to that in United Kingdom?
Provide a succinct answer. 0.35. What is the ratio of the PFC emissions (in thousand metric tons of CO2 equivalent) of 2000 in Turkey to that in United Kingdom?
Provide a succinct answer. 0.62. What is the ratio of the PFC emissions (in thousand metric tons of CO2 equivalent) in 2008 in Turkey to that in United Kingdom?
Provide a short and direct response. 1.25. What is the ratio of the PFC emissions (in thousand metric tons of CO2 equivalent) in 1990 in Turkey to that in United States?
Your answer should be compact. 0.03. What is the ratio of the PFC emissions (in thousand metric tons of CO2 equivalent) in 2000 in Turkey to that in United States?
Your response must be concise. 0.04. What is the ratio of the PFC emissions (in thousand metric tons of CO2 equivalent) of 2005 in Turkey to that in United States?
Offer a terse response. 0.06. What is the ratio of the PFC emissions (in thousand metric tons of CO2 equivalent) of 2008 in Turkey to that in United States?
Ensure brevity in your answer.  0.07. What is the ratio of the PFC emissions (in thousand metric tons of CO2 equivalent) of 1990 in Turkey to that in Venezuela?
Your answer should be compact. 0.28. What is the ratio of the PFC emissions (in thousand metric tons of CO2 equivalent) in 2000 in Turkey to that in Venezuela?
Give a very brief answer. 1.19. What is the ratio of the PFC emissions (in thousand metric tons of CO2 equivalent) in 2005 in Turkey to that in Venezuela?
Give a very brief answer. 1.91. What is the ratio of the PFC emissions (in thousand metric tons of CO2 equivalent) in 2008 in Turkey to that in Venezuela?
Your answer should be compact. 2.08. What is the ratio of the PFC emissions (in thousand metric tons of CO2 equivalent) of 1990 in Ukraine to that in United Arab Emirates?
Offer a very short reply. 0.58. What is the ratio of the PFC emissions (in thousand metric tons of CO2 equivalent) of 2000 in Ukraine to that in United Arab Emirates?
Keep it short and to the point. 1.12. What is the ratio of the PFC emissions (in thousand metric tons of CO2 equivalent) in 2005 in Ukraine to that in United Arab Emirates?
Provide a succinct answer. 0.67. What is the ratio of the PFC emissions (in thousand metric tons of CO2 equivalent) of 2008 in Ukraine to that in United Arab Emirates?
Offer a terse response. 0.52. What is the ratio of the PFC emissions (in thousand metric tons of CO2 equivalent) of 1990 in Ukraine to that in United Kingdom?
Your answer should be compact. 0.14. What is the ratio of the PFC emissions (in thousand metric tons of CO2 equivalent) of 2000 in Ukraine to that in United Kingdom?
Make the answer very short. 0.27. What is the ratio of the PFC emissions (in thousand metric tons of CO2 equivalent) of 2005 in Ukraine to that in United Kingdom?
Offer a terse response. 0.31. What is the ratio of the PFC emissions (in thousand metric tons of CO2 equivalent) of 2008 in Ukraine to that in United Kingdom?
Provide a succinct answer. 0.37. What is the ratio of the PFC emissions (in thousand metric tons of CO2 equivalent) of 1990 in Ukraine to that in United States?
Your response must be concise. 0.01. What is the ratio of the PFC emissions (in thousand metric tons of CO2 equivalent) in 2000 in Ukraine to that in United States?
Your answer should be very brief. 0.02. What is the ratio of the PFC emissions (in thousand metric tons of CO2 equivalent) in 2005 in Ukraine to that in United States?
Your answer should be very brief. 0.02. What is the ratio of the PFC emissions (in thousand metric tons of CO2 equivalent) of 2008 in Ukraine to that in United States?
Your answer should be compact. 0.02. What is the ratio of the PFC emissions (in thousand metric tons of CO2 equivalent) in 1990 in Ukraine to that in Venezuela?
Make the answer very short. 0.11. What is the ratio of the PFC emissions (in thousand metric tons of CO2 equivalent) of 2000 in Ukraine to that in Venezuela?
Ensure brevity in your answer.  0.53. What is the ratio of the PFC emissions (in thousand metric tons of CO2 equivalent) in 2005 in Ukraine to that in Venezuela?
Provide a short and direct response. 0.63. What is the ratio of the PFC emissions (in thousand metric tons of CO2 equivalent) of 2008 in Ukraine to that in Venezuela?
Offer a terse response. 0.62. What is the ratio of the PFC emissions (in thousand metric tons of CO2 equivalent) in 1990 in United Arab Emirates to that in United Kingdom?
Your answer should be very brief. 0.25. What is the ratio of the PFC emissions (in thousand metric tons of CO2 equivalent) in 2000 in United Arab Emirates to that in United Kingdom?
Offer a terse response. 0.24. What is the ratio of the PFC emissions (in thousand metric tons of CO2 equivalent) of 2005 in United Arab Emirates to that in United Kingdom?
Offer a very short reply. 0.45. What is the ratio of the PFC emissions (in thousand metric tons of CO2 equivalent) in 2008 in United Arab Emirates to that in United Kingdom?
Keep it short and to the point. 0.71. What is the ratio of the PFC emissions (in thousand metric tons of CO2 equivalent) in 1990 in United Arab Emirates to that in United States?
Ensure brevity in your answer.  0.02. What is the ratio of the PFC emissions (in thousand metric tons of CO2 equivalent) in 2000 in United Arab Emirates to that in United States?
Make the answer very short. 0.01. What is the ratio of the PFC emissions (in thousand metric tons of CO2 equivalent) of 2005 in United Arab Emirates to that in United States?
Your answer should be very brief. 0.03. What is the ratio of the PFC emissions (in thousand metric tons of CO2 equivalent) of 2008 in United Arab Emirates to that in United States?
Your response must be concise. 0.04. What is the ratio of the PFC emissions (in thousand metric tons of CO2 equivalent) in 1990 in United Arab Emirates to that in Venezuela?
Your answer should be very brief. 0.2. What is the ratio of the PFC emissions (in thousand metric tons of CO2 equivalent) of 2000 in United Arab Emirates to that in Venezuela?
Offer a very short reply. 0.47. What is the ratio of the PFC emissions (in thousand metric tons of CO2 equivalent) in 2005 in United Arab Emirates to that in Venezuela?
Keep it short and to the point. 0.94. What is the ratio of the PFC emissions (in thousand metric tons of CO2 equivalent) of 2008 in United Arab Emirates to that in Venezuela?
Your response must be concise. 1.19. What is the ratio of the PFC emissions (in thousand metric tons of CO2 equivalent) in 1990 in United Kingdom to that in United States?
Ensure brevity in your answer.  0.07. What is the ratio of the PFC emissions (in thousand metric tons of CO2 equivalent) in 2000 in United Kingdom to that in United States?
Your answer should be compact. 0.06. What is the ratio of the PFC emissions (in thousand metric tons of CO2 equivalent) of 2005 in United Kingdom to that in United States?
Keep it short and to the point. 0.07. What is the ratio of the PFC emissions (in thousand metric tons of CO2 equivalent) in 2008 in United Kingdom to that in United States?
Your response must be concise. 0.06. What is the ratio of the PFC emissions (in thousand metric tons of CO2 equivalent) in 1990 in United Kingdom to that in Venezuela?
Your answer should be compact. 0.8. What is the ratio of the PFC emissions (in thousand metric tons of CO2 equivalent) in 2000 in United Kingdom to that in Venezuela?
Offer a terse response. 1.92. What is the ratio of the PFC emissions (in thousand metric tons of CO2 equivalent) in 2005 in United Kingdom to that in Venezuela?
Offer a very short reply. 2.07. What is the ratio of the PFC emissions (in thousand metric tons of CO2 equivalent) of 2008 in United Kingdom to that in Venezuela?
Offer a terse response. 1.66. What is the ratio of the PFC emissions (in thousand metric tons of CO2 equivalent) in 1990 in United States to that in Venezuela?
Provide a succinct answer. 10.7. What is the ratio of the PFC emissions (in thousand metric tons of CO2 equivalent) in 2000 in United States to that in Venezuela?
Your response must be concise. 31.72. What is the ratio of the PFC emissions (in thousand metric tons of CO2 equivalent) of 2005 in United States to that in Venezuela?
Offer a very short reply. 31.49. What is the ratio of the PFC emissions (in thousand metric tons of CO2 equivalent) in 2008 in United States to that in Venezuela?
Your answer should be very brief. 29.12. What is the difference between the highest and the second highest PFC emissions (in thousand metric tons of CO2 equivalent) in 1990?
Offer a terse response. 1.89e+04. What is the difference between the highest and the second highest PFC emissions (in thousand metric tons of CO2 equivalent) of 2000?
Your response must be concise. 1.38e+04. What is the difference between the highest and the second highest PFC emissions (in thousand metric tons of CO2 equivalent) in 2005?
Your answer should be compact. 8417.3. What is the difference between the highest and the second highest PFC emissions (in thousand metric tons of CO2 equivalent) in 2008?
Your answer should be very brief. 7672.6. What is the difference between the highest and the lowest PFC emissions (in thousand metric tons of CO2 equivalent) of 1990?
Make the answer very short. 2.06e+04. What is the difference between the highest and the lowest PFC emissions (in thousand metric tons of CO2 equivalent) in 2000?
Offer a very short reply. 1.45e+04. What is the difference between the highest and the lowest PFC emissions (in thousand metric tons of CO2 equivalent) of 2005?
Keep it short and to the point. 8828.2. What is the difference between the highest and the lowest PFC emissions (in thousand metric tons of CO2 equivalent) in 2008?
Your answer should be compact. 8087.5. 